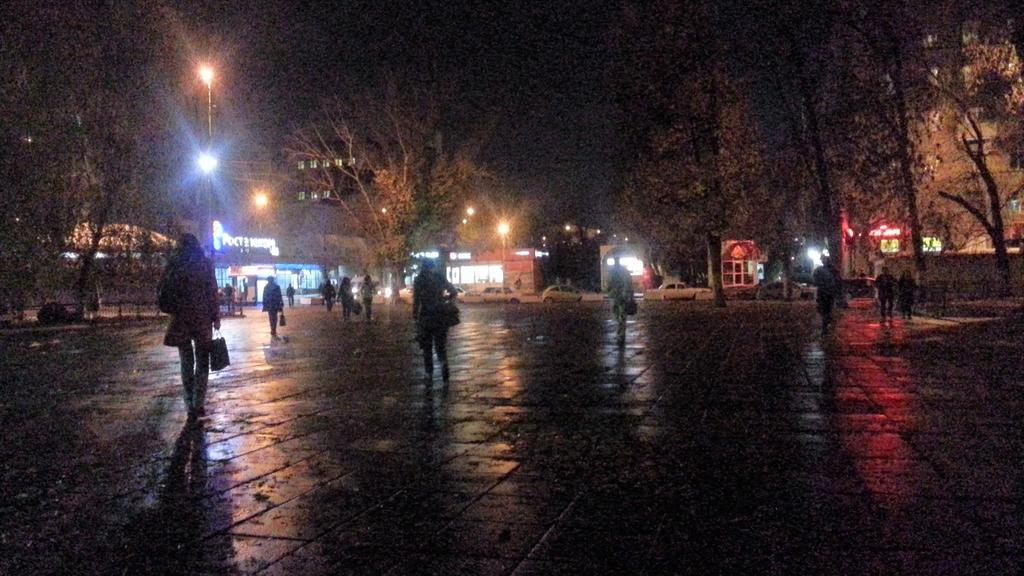Where was the image taken? The image was clicked outside. What is the main subject of the image? There is a group of people in the center of the image. What are the people in the image doing? The people are walking on the ground. What can be seen in the background of the image? There are trees, lights, and buildings in the background of the image. Can you see a goose producing a badge in the image? No, there is no goose or badge present in the image. 